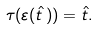<formula> <loc_0><loc_0><loc_500><loc_500>\tau ( \varepsilon ( \hat { t } \, ) ) = \hat { t } .</formula> 